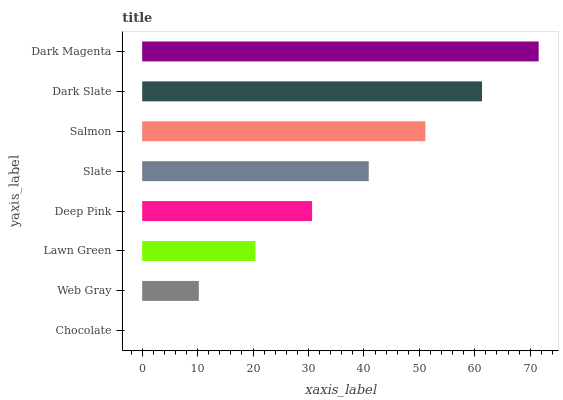Is Chocolate the minimum?
Answer yes or no. Yes. Is Dark Magenta the maximum?
Answer yes or no. Yes. Is Web Gray the minimum?
Answer yes or no. No. Is Web Gray the maximum?
Answer yes or no. No. Is Web Gray greater than Chocolate?
Answer yes or no. Yes. Is Chocolate less than Web Gray?
Answer yes or no. Yes. Is Chocolate greater than Web Gray?
Answer yes or no. No. Is Web Gray less than Chocolate?
Answer yes or no. No. Is Slate the high median?
Answer yes or no. Yes. Is Deep Pink the low median?
Answer yes or no. Yes. Is Deep Pink the high median?
Answer yes or no. No. Is Dark Slate the low median?
Answer yes or no. No. 